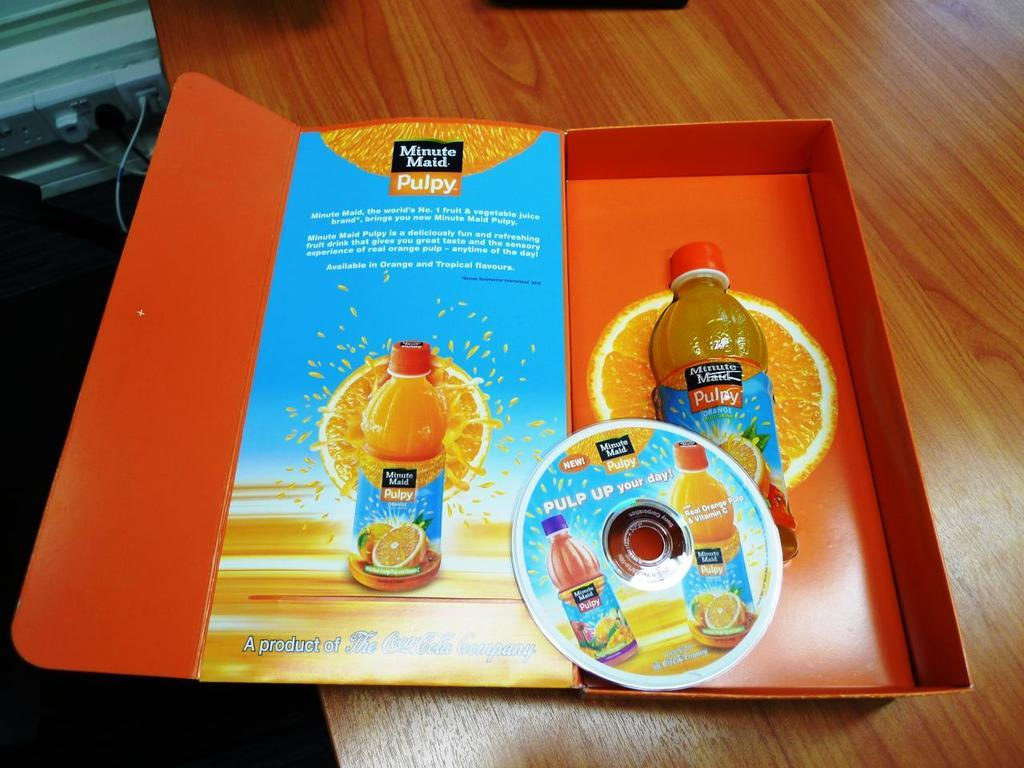What type of furniture is present in the image? There is a table in the image. What is on the table in the image? There is a box of Minute Maid pulpy juice on the table. Where are the cattle located in the image? There are no cattle present in the image. What type of brush is used to paint the box of juice in the image? The image does not show the process of painting the box of juice, nor does it depict any brushes. 